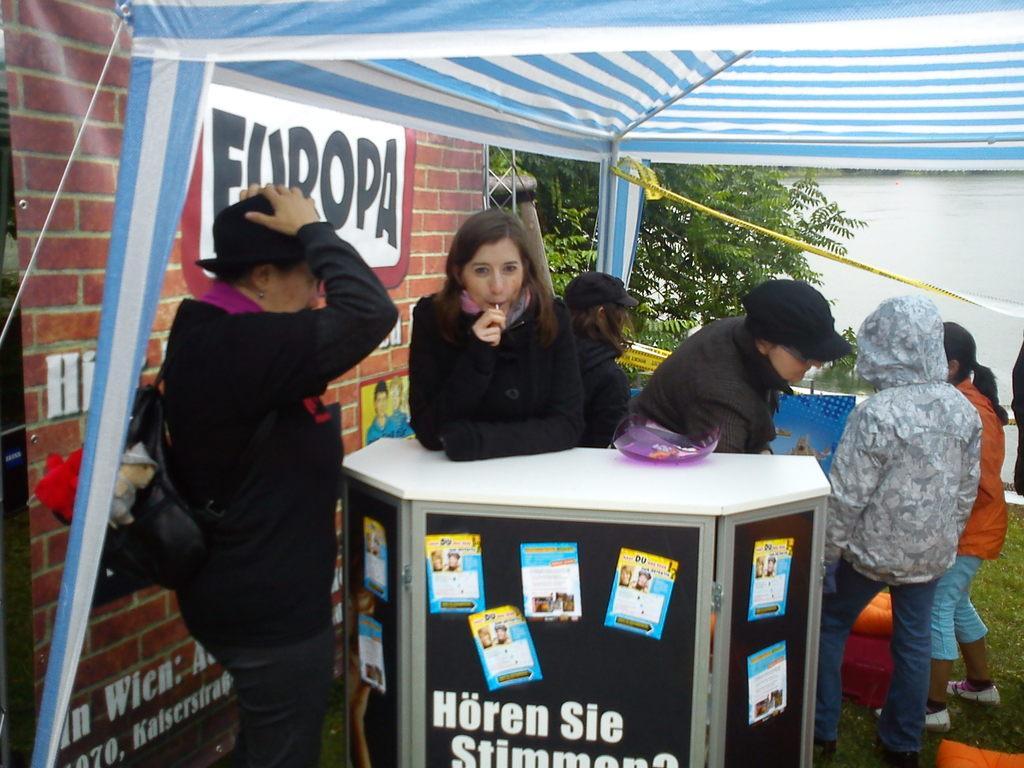Please provide a concise description of this image. There is a woman standing and placed her hands on a table in front of her and holding an object in her hand which is placed in her mouth and there are few other persons beside her and there are water and a tree in the background. 